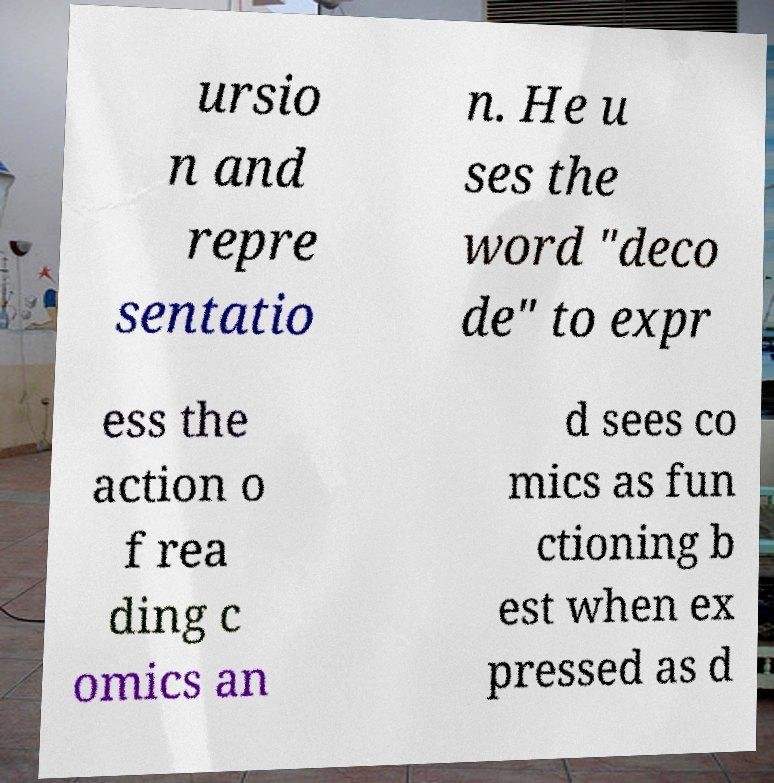What messages or text are displayed in this image? I need them in a readable, typed format. ursio n and repre sentatio n. He u ses the word "deco de" to expr ess the action o f rea ding c omics an d sees co mics as fun ctioning b est when ex pressed as d 